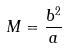Convert formula to latex. <formula><loc_0><loc_0><loc_500><loc_500>M = \frac { b ^ { 2 } } { a }</formula> 